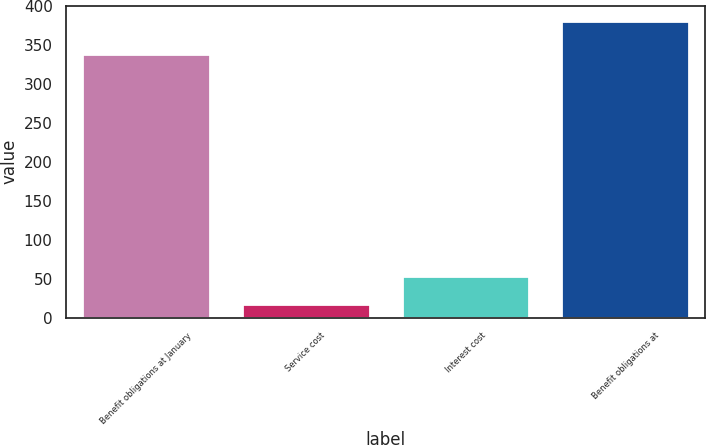Convert chart to OTSL. <chart><loc_0><loc_0><loc_500><loc_500><bar_chart><fcel>Benefit obligations at January<fcel>Service cost<fcel>Interest cost<fcel>Benefit obligations at<nl><fcel>338<fcel>17<fcel>53.4<fcel>381<nl></chart> 